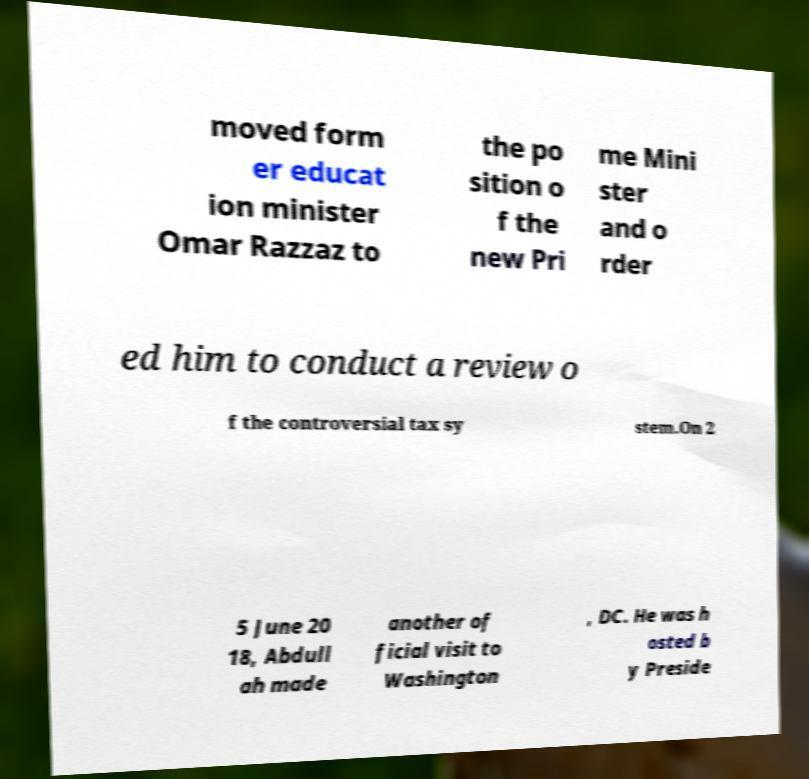Can you accurately transcribe the text from the provided image for me? moved form er educat ion minister Omar Razzaz to the po sition o f the new Pri me Mini ster and o rder ed him to conduct a review o f the controversial tax sy stem.On 2 5 June 20 18, Abdull ah made another of ficial visit to Washington , DC. He was h osted b y Preside 